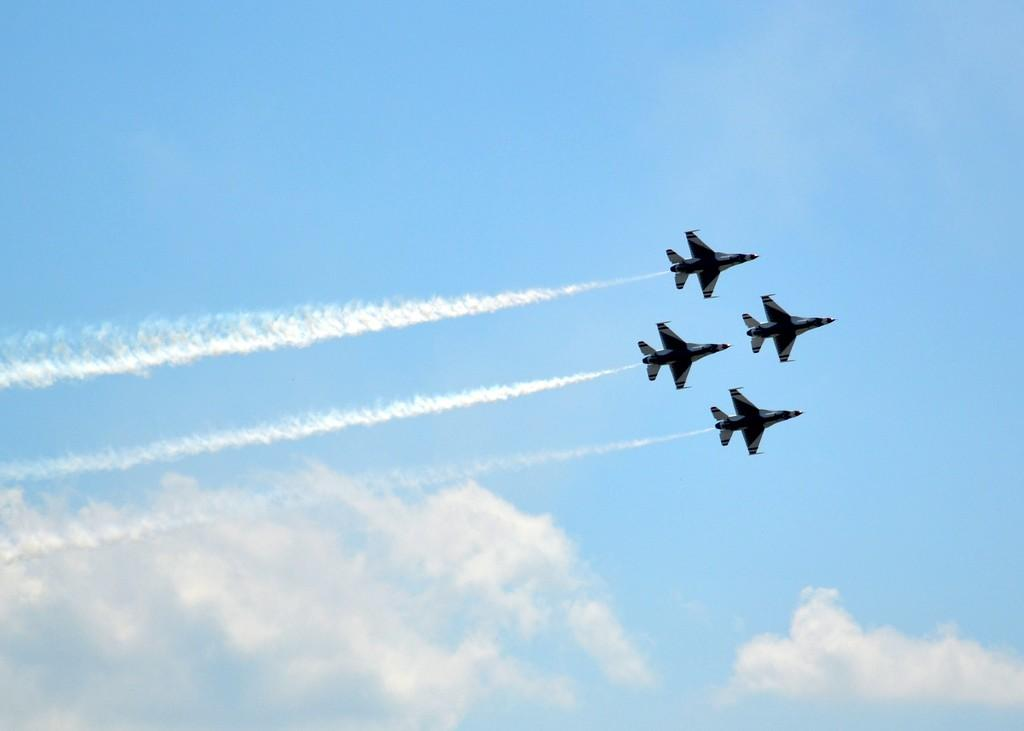What is the main subject of the image? The main subject of the image is airplanes. What are the airplanes doing in the image? The airplanes are flying in the sky. What color is the silk elbow pad on the airplane in the image? There is no silk elbow pad present on the airplanes in the image. 